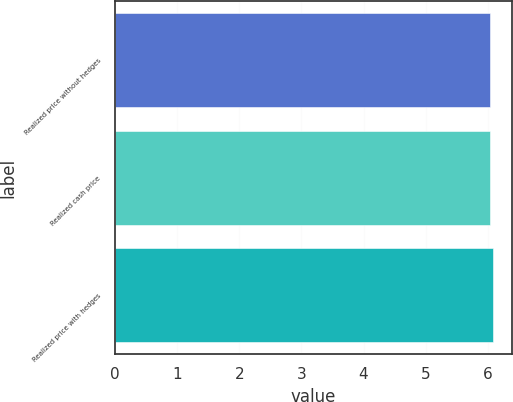Convert chart to OTSL. <chart><loc_0><loc_0><loc_500><loc_500><bar_chart><fcel>Realized price without hedges<fcel>Realized cash price<fcel>Realized price with hedges<nl><fcel>6.03<fcel>6.04<fcel>6.08<nl></chart> 